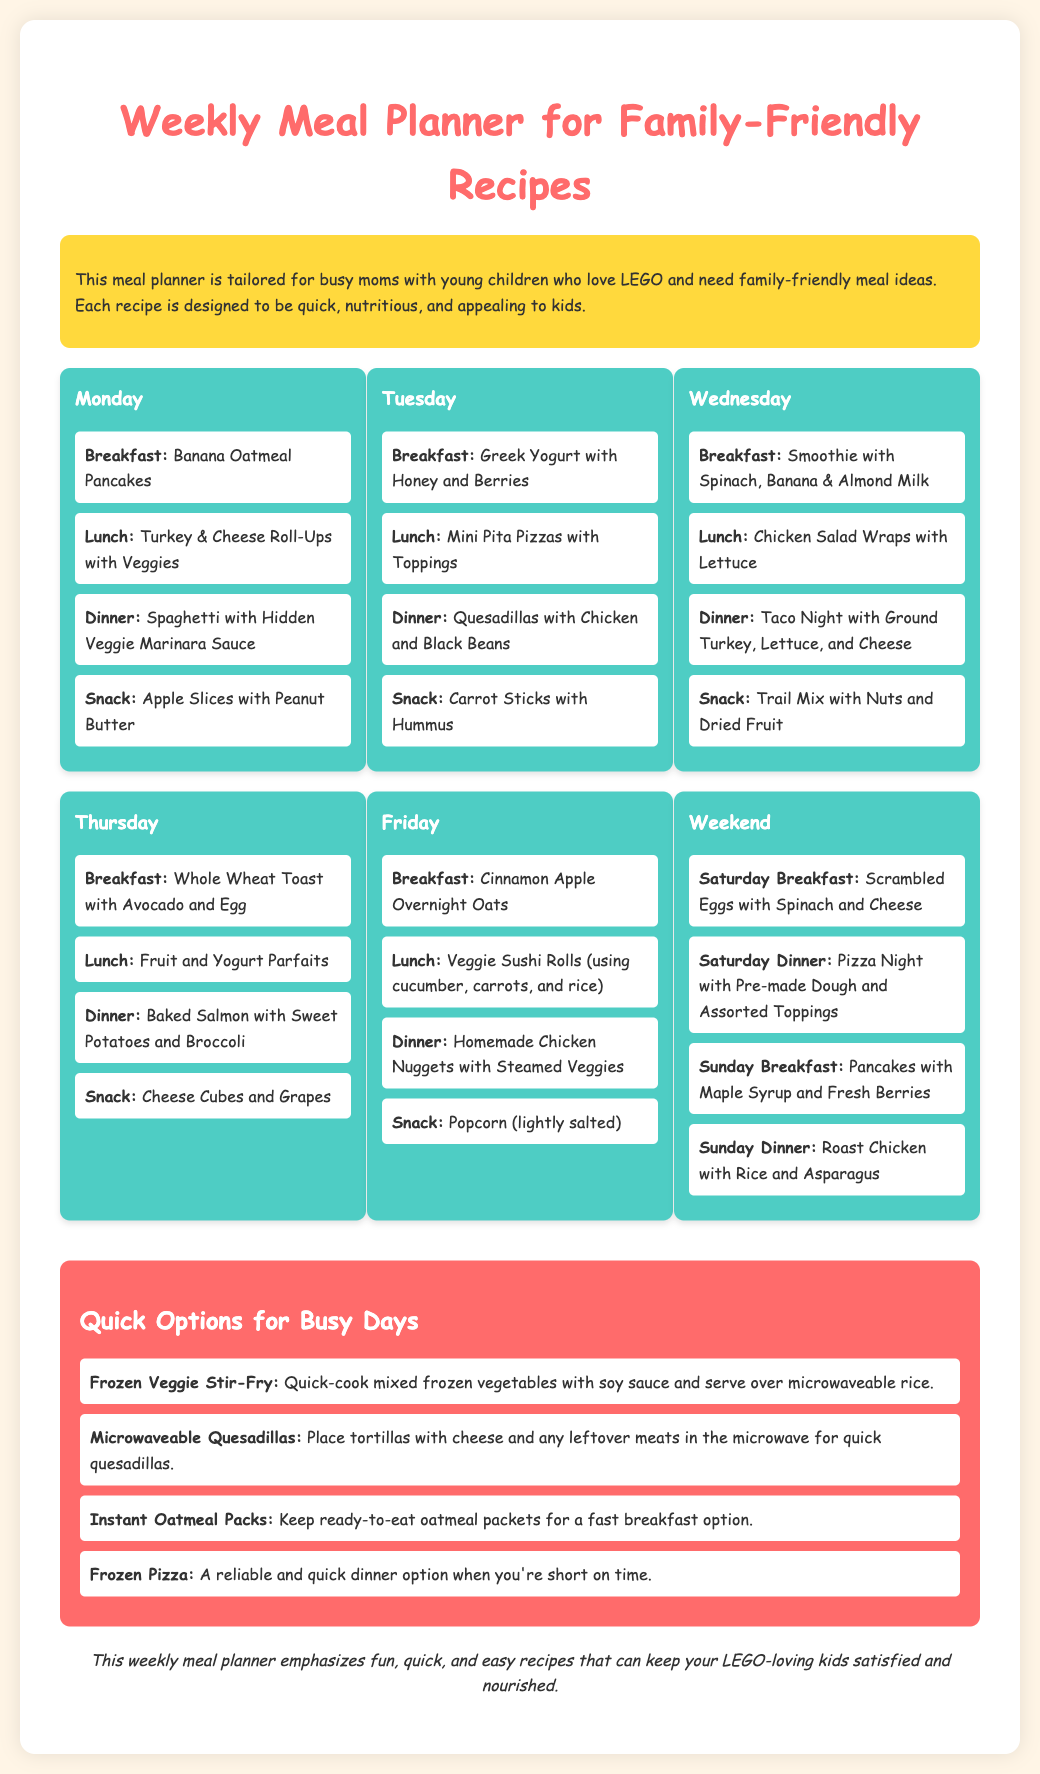What is the title of the document? The title of the document is found in the header section of the webpage.
Answer: Weekly Meal Planner for Family-Friendly Recipes What is the main audience for this meal planner? The introduction section describes who the meal planner is tailored for, emphasizing busy moms.
Answer: Busy moms What is the breakfast option for Tuesday? The breakfast options are listed under each weekday in the meal plan section.
Answer: Greek Yogurt with Honey and Berries What snack is suggested for Wednesday? Snacks are detailed under each day's meal plan; the answer is found in the Wednesday section.
Answer: Trail Mix with Nuts and Dried Fruit How many quick options are provided? The quick options are specified in a dedicated section, which mentions several items listed under it.
Answer: Four What is the recommended Saturday dinner? The Saturday dinner is listed as part of the weekend meal options in the meal plan section.
Answer: Pizza Night with Pre-made Dough and Assorted Toppings What kind of pancakes are listed for Monday’s breakfast? The breakfast on Monday specifies a type of recipe in the meal plan section.
Answer: Banana Oatmeal Pancakes Which lunch option includes cheese? The lunch options are listed for different days; the reasoning involves checking for cheese in the meals.
Answer: Mini Pita Pizzas with Toppings What is the color of the section displaying quick options? The color can be inferred from the CSS styling indicated above, specifically for the quick options section.
Answer: Light red 